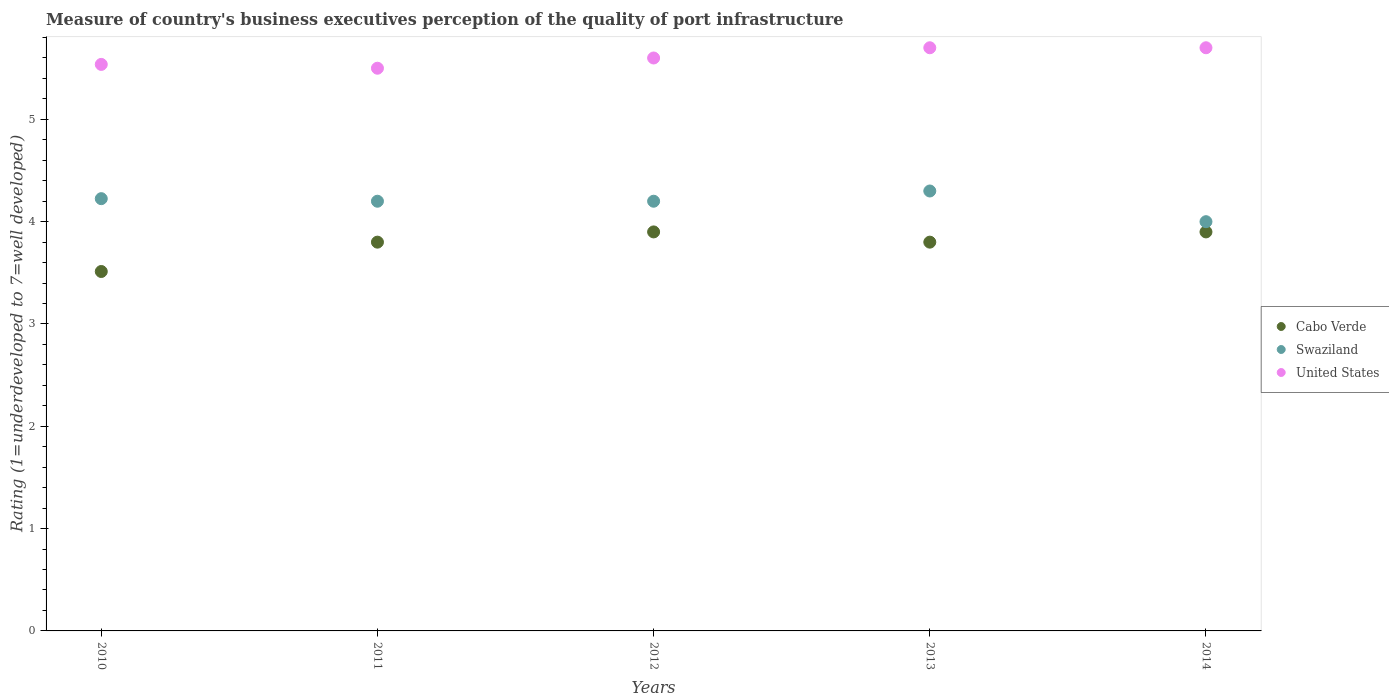How many different coloured dotlines are there?
Your response must be concise. 3. Is the number of dotlines equal to the number of legend labels?
Your response must be concise. Yes. What is the ratings of the quality of port infrastructure in Swaziland in 2010?
Provide a short and direct response. 4.23. Across all years, what is the minimum ratings of the quality of port infrastructure in United States?
Give a very brief answer. 5.5. In which year was the ratings of the quality of port infrastructure in United States maximum?
Your answer should be very brief. 2013. What is the total ratings of the quality of port infrastructure in Cabo Verde in the graph?
Give a very brief answer. 18.91. What is the difference between the ratings of the quality of port infrastructure in Swaziland in 2010 and that in 2013?
Make the answer very short. -0.07. What is the difference between the ratings of the quality of port infrastructure in Cabo Verde in 2010 and the ratings of the quality of port infrastructure in Swaziland in 2012?
Give a very brief answer. -0.69. What is the average ratings of the quality of port infrastructure in United States per year?
Your answer should be very brief. 5.61. In the year 2011, what is the difference between the ratings of the quality of port infrastructure in Swaziland and ratings of the quality of port infrastructure in Cabo Verde?
Your answer should be compact. 0.4. In how many years, is the ratings of the quality of port infrastructure in Swaziland greater than 1.6?
Make the answer very short. 5. Is the ratings of the quality of port infrastructure in United States in 2011 less than that in 2012?
Provide a short and direct response. Yes. What is the difference between the highest and the second highest ratings of the quality of port infrastructure in Cabo Verde?
Keep it short and to the point. 0. What is the difference between the highest and the lowest ratings of the quality of port infrastructure in Cabo Verde?
Give a very brief answer. 0.39. In how many years, is the ratings of the quality of port infrastructure in Cabo Verde greater than the average ratings of the quality of port infrastructure in Cabo Verde taken over all years?
Your response must be concise. 4. Is the sum of the ratings of the quality of port infrastructure in United States in 2011 and 2014 greater than the maximum ratings of the quality of port infrastructure in Cabo Verde across all years?
Provide a succinct answer. Yes. Is it the case that in every year, the sum of the ratings of the quality of port infrastructure in Cabo Verde and ratings of the quality of port infrastructure in United States  is greater than the ratings of the quality of port infrastructure in Swaziland?
Offer a very short reply. Yes. Does the ratings of the quality of port infrastructure in Swaziland monotonically increase over the years?
Your answer should be very brief. No. Is the ratings of the quality of port infrastructure in Swaziland strictly greater than the ratings of the quality of port infrastructure in Cabo Verde over the years?
Your answer should be compact. Yes. How many dotlines are there?
Offer a terse response. 3. What is the difference between two consecutive major ticks on the Y-axis?
Your response must be concise. 1. Are the values on the major ticks of Y-axis written in scientific E-notation?
Offer a terse response. No. Does the graph contain any zero values?
Your response must be concise. No. Does the graph contain grids?
Ensure brevity in your answer.  No. Where does the legend appear in the graph?
Your response must be concise. Center right. How many legend labels are there?
Offer a very short reply. 3. How are the legend labels stacked?
Keep it short and to the point. Vertical. What is the title of the graph?
Provide a succinct answer. Measure of country's business executives perception of the quality of port infrastructure. Does "Samoa" appear as one of the legend labels in the graph?
Offer a terse response. No. What is the label or title of the X-axis?
Ensure brevity in your answer.  Years. What is the label or title of the Y-axis?
Ensure brevity in your answer.  Rating (1=underdeveloped to 7=well developed). What is the Rating (1=underdeveloped to 7=well developed) in Cabo Verde in 2010?
Make the answer very short. 3.51. What is the Rating (1=underdeveloped to 7=well developed) in Swaziland in 2010?
Ensure brevity in your answer.  4.23. What is the Rating (1=underdeveloped to 7=well developed) of United States in 2010?
Offer a very short reply. 5.54. What is the Rating (1=underdeveloped to 7=well developed) in Cabo Verde in 2011?
Your answer should be very brief. 3.8. What is the Rating (1=underdeveloped to 7=well developed) of Swaziland in 2011?
Give a very brief answer. 4.2. What is the Rating (1=underdeveloped to 7=well developed) of Swaziland in 2012?
Give a very brief answer. 4.2. Across all years, what is the maximum Rating (1=underdeveloped to 7=well developed) of Cabo Verde?
Your answer should be compact. 3.9. Across all years, what is the maximum Rating (1=underdeveloped to 7=well developed) in Swaziland?
Offer a terse response. 4.3. Across all years, what is the maximum Rating (1=underdeveloped to 7=well developed) of United States?
Ensure brevity in your answer.  5.7. Across all years, what is the minimum Rating (1=underdeveloped to 7=well developed) of Cabo Verde?
Provide a succinct answer. 3.51. Across all years, what is the minimum Rating (1=underdeveloped to 7=well developed) in Swaziland?
Ensure brevity in your answer.  4. Across all years, what is the minimum Rating (1=underdeveloped to 7=well developed) of United States?
Offer a terse response. 5.5. What is the total Rating (1=underdeveloped to 7=well developed) in Cabo Verde in the graph?
Your answer should be compact. 18.91. What is the total Rating (1=underdeveloped to 7=well developed) of Swaziland in the graph?
Offer a terse response. 20.93. What is the total Rating (1=underdeveloped to 7=well developed) of United States in the graph?
Ensure brevity in your answer.  28.04. What is the difference between the Rating (1=underdeveloped to 7=well developed) in Cabo Verde in 2010 and that in 2011?
Give a very brief answer. -0.29. What is the difference between the Rating (1=underdeveloped to 7=well developed) of Swaziland in 2010 and that in 2011?
Give a very brief answer. 0.03. What is the difference between the Rating (1=underdeveloped to 7=well developed) of United States in 2010 and that in 2011?
Your response must be concise. 0.04. What is the difference between the Rating (1=underdeveloped to 7=well developed) in Cabo Verde in 2010 and that in 2012?
Keep it short and to the point. -0.39. What is the difference between the Rating (1=underdeveloped to 7=well developed) in Swaziland in 2010 and that in 2012?
Provide a succinct answer. 0.03. What is the difference between the Rating (1=underdeveloped to 7=well developed) in United States in 2010 and that in 2012?
Make the answer very short. -0.06. What is the difference between the Rating (1=underdeveloped to 7=well developed) in Cabo Verde in 2010 and that in 2013?
Your answer should be very brief. -0.29. What is the difference between the Rating (1=underdeveloped to 7=well developed) in Swaziland in 2010 and that in 2013?
Offer a terse response. -0.07. What is the difference between the Rating (1=underdeveloped to 7=well developed) in United States in 2010 and that in 2013?
Ensure brevity in your answer.  -0.16. What is the difference between the Rating (1=underdeveloped to 7=well developed) of Cabo Verde in 2010 and that in 2014?
Your answer should be compact. -0.39. What is the difference between the Rating (1=underdeveloped to 7=well developed) in Swaziland in 2010 and that in 2014?
Your answer should be compact. 0.23. What is the difference between the Rating (1=underdeveloped to 7=well developed) in United States in 2010 and that in 2014?
Offer a terse response. -0.16. What is the difference between the Rating (1=underdeveloped to 7=well developed) in Cabo Verde in 2011 and that in 2013?
Your answer should be very brief. 0. What is the difference between the Rating (1=underdeveloped to 7=well developed) of United States in 2011 and that in 2013?
Give a very brief answer. -0.2. What is the difference between the Rating (1=underdeveloped to 7=well developed) in Swaziland in 2011 and that in 2014?
Your response must be concise. 0.2. What is the difference between the Rating (1=underdeveloped to 7=well developed) in Cabo Verde in 2012 and that in 2013?
Ensure brevity in your answer.  0.1. What is the difference between the Rating (1=underdeveloped to 7=well developed) in Swaziland in 2012 and that in 2013?
Offer a very short reply. -0.1. What is the difference between the Rating (1=underdeveloped to 7=well developed) in United States in 2012 and that in 2013?
Your answer should be very brief. -0.1. What is the difference between the Rating (1=underdeveloped to 7=well developed) in Swaziland in 2012 and that in 2014?
Provide a short and direct response. 0.2. What is the difference between the Rating (1=underdeveloped to 7=well developed) in Swaziland in 2013 and that in 2014?
Make the answer very short. 0.3. What is the difference between the Rating (1=underdeveloped to 7=well developed) of United States in 2013 and that in 2014?
Offer a terse response. 0. What is the difference between the Rating (1=underdeveloped to 7=well developed) in Cabo Verde in 2010 and the Rating (1=underdeveloped to 7=well developed) in Swaziland in 2011?
Provide a succinct answer. -0.69. What is the difference between the Rating (1=underdeveloped to 7=well developed) of Cabo Verde in 2010 and the Rating (1=underdeveloped to 7=well developed) of United States in 2011?
Ensure brevity in your answer.  -1.99. What is the difference between the Rating (1=underdeveloped to 7=well developed) of Swaziland in 2010 and the Rating (1=underdeveloped to 7=well developed) of United States in 2011?
Offer a terse response. -1.27. What is the difference between the Rating (1=underdeveloped to 7=well developed) of Cabo Verde in 2010 and the Rating (1=underdeveloped to 7=well developed) of Swaziland in 2012?
Your response must be concise. -0.69. What is the difference between the Rating (1=underdeveloped to 7=well developed) in Cabo Verde in 2010 and the Rating (1=underdeveloped to 7=well developed) in United States in 2012?
Provide a short and direct response. -2.09. What is the difference between the Rating (1=underdeveloped to 7=well developed) of Swaziland in 2010 and the Rating (1=underdeveloped to 7=well developed) of United States in 2012?
Make the answer very short. -1.38. What is the difference between the Rating (1=underdeveloped to 7=well developed) of Cabo Verde in 2010 and the Rating (1=underdeveloped to 7=well developed) of Swaziland in 2013?
Give a very brief answer. -0.79. What is the difference between the Rating (1=underdeveloped to 7=well developed) in Cabo Verde in 2010 and the Rating (1=underdeveloped to 7=well developed) in United States in 2013?
Provide a short and direct response. -2.19. What is the difference between the Rating (1=underdeveloped to 7=well developed) of Swaziland in 2010 and the Rating (1=underdeveloped to 7=well developed) of United States in 2013?
Your answer should be very brief. -1.48. What is the difference between the Rating (1=underdeveloped to 7=well developed) in Cabo Verde in 2010 and the Rating (1=underdeveloped to 7=well developed) in Swaziland in 2014?
Provide a succinct answer. -0.49. What is the difference between the Rating (1=underdeveloped to 7=well developed) of Cabo Verde in 2010 and the Rating (1=underdeveloped to 7=well developed) of United States in 2014?
Ensure brevity in your answer.  -2.19. What is the difference between the Rating (1=underdeveloped to 7=well developed) in Swaziland in 2010 and the Rating (1=underdeveloped to 7=well developed) in United States in 2014?
Offer a very short reply. -1.48. What is the difference between the Rating (1=underdeveloped to 7=well developed) in Cabo Verde in 2011 and the Rating (1=underdeveloped to 7=well developed) in Swaziland in 2012?
Your answer should be very brief. -0.4. What is the difference between the Rating (1=underdeveloped to 7=well developed) in Cabo Verde in 2011 and the Rating (1=underdeveloped to 7=well developed) in United States in 2012?
Provide a succinct answer. -1.8. What is the difference between the Rating (1=underdeveloped to 7=well developed) in Cabo Verde in 2011 and the Rating (1=underdeveloped to 7=well developed) in Swaziland in 2013?
Provide a succinct answer. -0.5. What is the difference between the Rating (1=underdeveloped to 7=well developed) in Cabo Verde in 2011 and the Rating (1=underdeveloped to 7=well developed) in United States in 2013?
Provide a succinct answer. -1.9. What is the difference between the Rating (1=underdeveloped to 7=well developed) of Cabo Verde in 2011 and the Rating (1=underdeveloped to 7=well developed) of United States in 2014?
Provide a succinct answer. -1.9. What is the difference between the Rating (1=underdeveloped to 7=well developed) of Cabo Verde in 2012 and the Rating (1=underdeveloped to 7=well developed) of Swaziland in 2013?
Make the answer very short. -0.4. What is the difference between the Rating (1=underdeveloped to 7=well developed) of Cabo Verde in 2012 and the Rating (1=underdeveloped to 7=well developed) of United States in 2013?
Offer a very short reply. -1.8. What is the difference between the Rating (1=underdeveloped to 7=well developed) of Swaziland in 2012 and the Rating (1=underdeveloped to 7=well developed) of United States in 2013?
Make the answer very short. -1.5. What is the difference between the Rating (1=underdeveloped to 7=well developed) in Swaziland in 2012 and the Rating (1=underdeveloped to 7=well developed) in United States in 2014?
Your answer should be compact. -1.5. What is the difference between the Rating (1=underdeveloped to 7=well developed) in Cabo Verde in 2013 and the Rating (1=underdeveloped to 7=well developed) in Swaziland in 2014?
Make the answer very short. -0.2. What is the difference between the Rating (1=underdeveloped to 7=well developed) in Swaziland in 2013 and the Rating (1=underdeveloped to 7=well developed) in United States in 2014?
Provide a succinct answer. -1.4. What is the average Rating (1=underdeveloped to 7=well developed) of Cabo Verde per year?
Offer a very short reply. 3.78. What is the average Rating (1=underdeveloped to 7=well developed) in Swaziland per year?
Provide a short and direct response. 4.18. What is the average Rating (1=underdeveloped to 7=well developed) in United States per year?
Provide a succinct answer. 5.61. In the year 2010, what is the difference between the Rating (1=underdeveloped to 7=well developed) of Cabo Verde and Rating (1=underdeveloped to 7=well developed) of Swaziland?
Make the answer very short. -0.71. In the year 2010, what is the difference between the Rating (1=underdeveloped to 7=well developed) in Cabo Verde and Rating (1=underdeveloped to 7=well developed) in United States?
Ensure brevity in your answer.  -2.02. In the year 2010, what is the difference between the Rating (1=underdeveloped to 7=well developed) in Swaziland and Rating (1=underdeveloped to 7=well developed) in United States?
Offer a very short reply. -1.31. In the year 2011, what is the difference between the Rating (1=underdeveloped to 7=well developed) of Swaziland and Rating (1=underdeveloped to 7=well developed) of United States?
Ensure brevity in your answer.  -1.3. In the year 2012, what is the difference between the Rating (1=underdeveloped to 7=well developed) of Cabo Verde and Rating (1=underdeveloped to 7=well developed) of Swaziland?
Ensure brevity in your answer.  -0.3. In the year 2012, what is the difference between the Rating (1=underdeveloped to 7=well developed) of Swaziland and Rating (1=underdeveloped to 7=well developed) of United States?
Ensure brevity in your answer.  -1.4. In the year 2013, what is the difference between the Rating (1=underdeveloped to 7=well developed) of Swaziland and Rating (1=underdeveloped to 7=well developed) of United States?
Your answer should be very brief. -1.4. What is the ratio of the Rating (1=underdeveloped to 7=well developed) of Cabo Verde in 2010 to that in 2011?
Provide a short and direct response. 0.92. What is the ratio of the Rating (1=underdeveloped to 7=well developed) in Swaziland in 2010 to that in 2011?
Keep it short and to the point. 1.01. What is the ratio of the Rating (1=underdeveloped to 7=well developed) in United States in 2010 to that in 2011?
Your answer should be compact. 1.01. What is the ratio of the Rating (1=underdeveloped to 7=well developed) in Cabo Verde in 2010 to that in 2012?
Your response must be concise. 0.9. What is the ratio of the Rating (1=underdeveloped to 7=well developed) in Swaziland in 2010 to that in 2012?
Keep it short and to the point. 1.01. What is the ratio of the Rating (1=underdeveloped to 7=well developed) in United States in 2010 to that in 2012?
Provide a short and direct response. 0.99. What is the ratio of the Rating (1=underdeveloped to 7=well developed) of Cabo Verde in 2010 to that in 2013?
Offer a very short reply. 0.92. What is the ratio of the Rating (1=underdeveloped to 7=well developed) in Swaziland in 2010 to that in 2013?
Your response must be concise. 0.98. What is the ratio of the Rating (1=underdeveloped to 7=well developed) in United States in 2010 to that in 2013?
Offer a very short reply. 0.97. What is the ratio of the Rating (1=underdeveloped to 7=well developed) in Cabo Verde in 2010 to that in 2014?
Make the answer very short. 0.9. What is the ratio of the Rating (1=underdeveloped to 7=well developed) of Swaziland in 2010 to that in 2014?
Make the answer very short. 1.06. What is the ratio of the Rating (1=underdeveloped to 7=well developed) of United States in 2010 to that in 2014?
Provide a short and direct response. 0.97. What is the ratio of the Rating (1=underdeveloped to 7=well developed) of Cabo Verde in 2011 to that in 2012?
Keep it short and to the point. 0.97. What is the ratio of the Rating (1=underdeveloped to 7=well developed) in Swaziland in 2011 to that in 2012?
Offer a terse response. 1. What is the ratio of the Rating (1=underdeveloped to 7=well developed) of United States in 2011 to that in 2012?
Make the answer very short. 0.98. What is the ratio of the Rating (1=underdeveloped to 7=well developed) in Swaziland in 2011 to that in 2013?
Offer a very short reply. 0.98. What is the ratio of the Rating (1=underdeveloped to 7=well developed) of United States in 2011 to that in 2013?
Your response must be concise. 0.96. What is the ratio of the Rating (1=underdeveloped to 7=well developed) of Cabo Verde in 2011 to that in 2014?
Offer a terse response. 0.97. What is the ratio of the Rating (1=underdeveloped to 7=well developed) in United States in 2011 to that in 2014?
Provide a short and direct response. 0.96. What is the ratio of the Rating (1=underdeveloped to 7=well developed) of Cabo Verde in 2012 to that in 2013?
Offer a very short reply. 1.03. What is the ratio of the Rating (1=underdeveloped to 7=well developed) of Swaziland in 2012 to that in 2013?
Offer a very short reply. 0.98. What is the ratio of the Rating (1=underdeveloped to 7=well developed) of United States in 2012 to that in 2013?
Your answer should be compact. 0.98. What is the ratio of the Rating (1=underdeveloped to 7=well developed) of United States in 2012 to that in 2014?
Make the answer very short. 0.98. What is the ratio of the Rating (1=underdeveloped to 7=well developed) in Cabo Verde in 2013 to that in 2014?
Offer a terse response. 0.97. What is the ratio of the Rating (1=underdeveloped to 7=well developed) of Swaziland in 2013 to that in 2014?
Make the answer very short. 1.07. What is the difference between the highest and the second highest Rating (1=underdeveloped to 7=well developed) of Cabo Verde?
Your answer should be very brief. 0. What is the difference between the highest and the second highest Rating (1=underdeveloped to 7=well developed) of Swaziland?
Give a very brief answer. 0.07. What is the difference between the highest and the lowest Rating (1=underdeveloped to 7=well developed) in Cabo Verde?
Provide a short and direct response. 0.39. What is the difference between the highest and the lowest Rating (1=underdeveloped to 7=well developed) in United States?
Your answer should be compact. 0.2. 